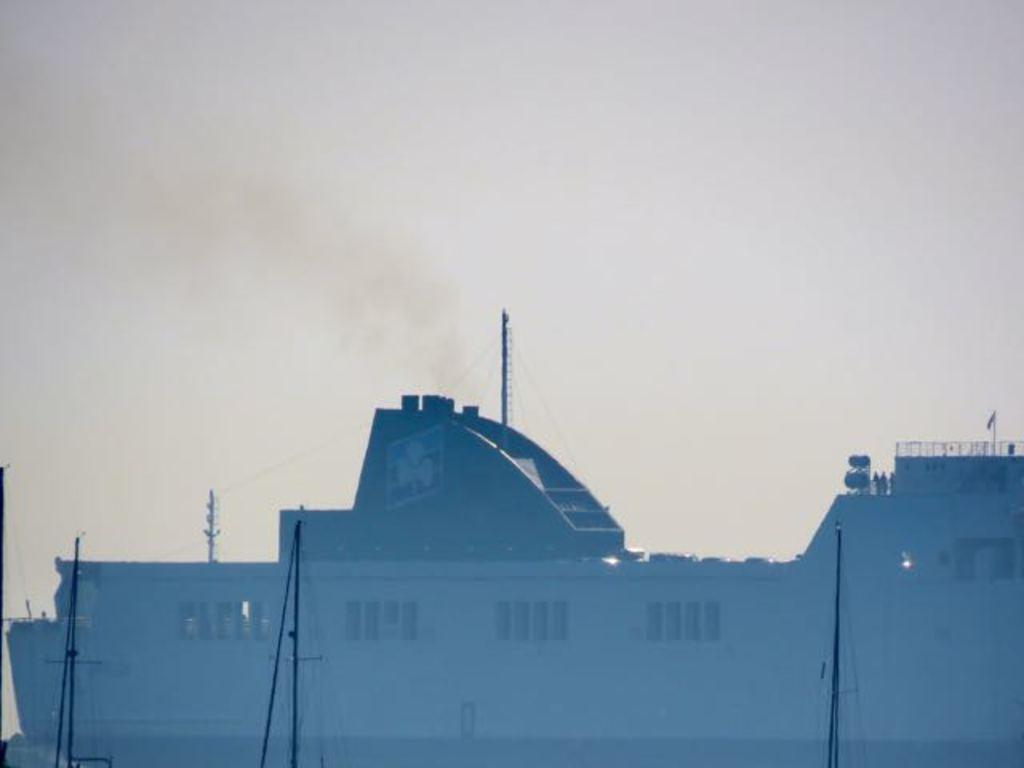What type of structure is visible in the image? There is a building in the image. What other objects can be seen near the building? Current poles are present in the image. Are there any people in the image? Yes, there are people standing on the building. What is visible at the top of the image? The sky is visible at the top of the image. What type of powder is being used by the people standing on the building in the image? There is no powder visible in the image; the people are simply standing on the building. 